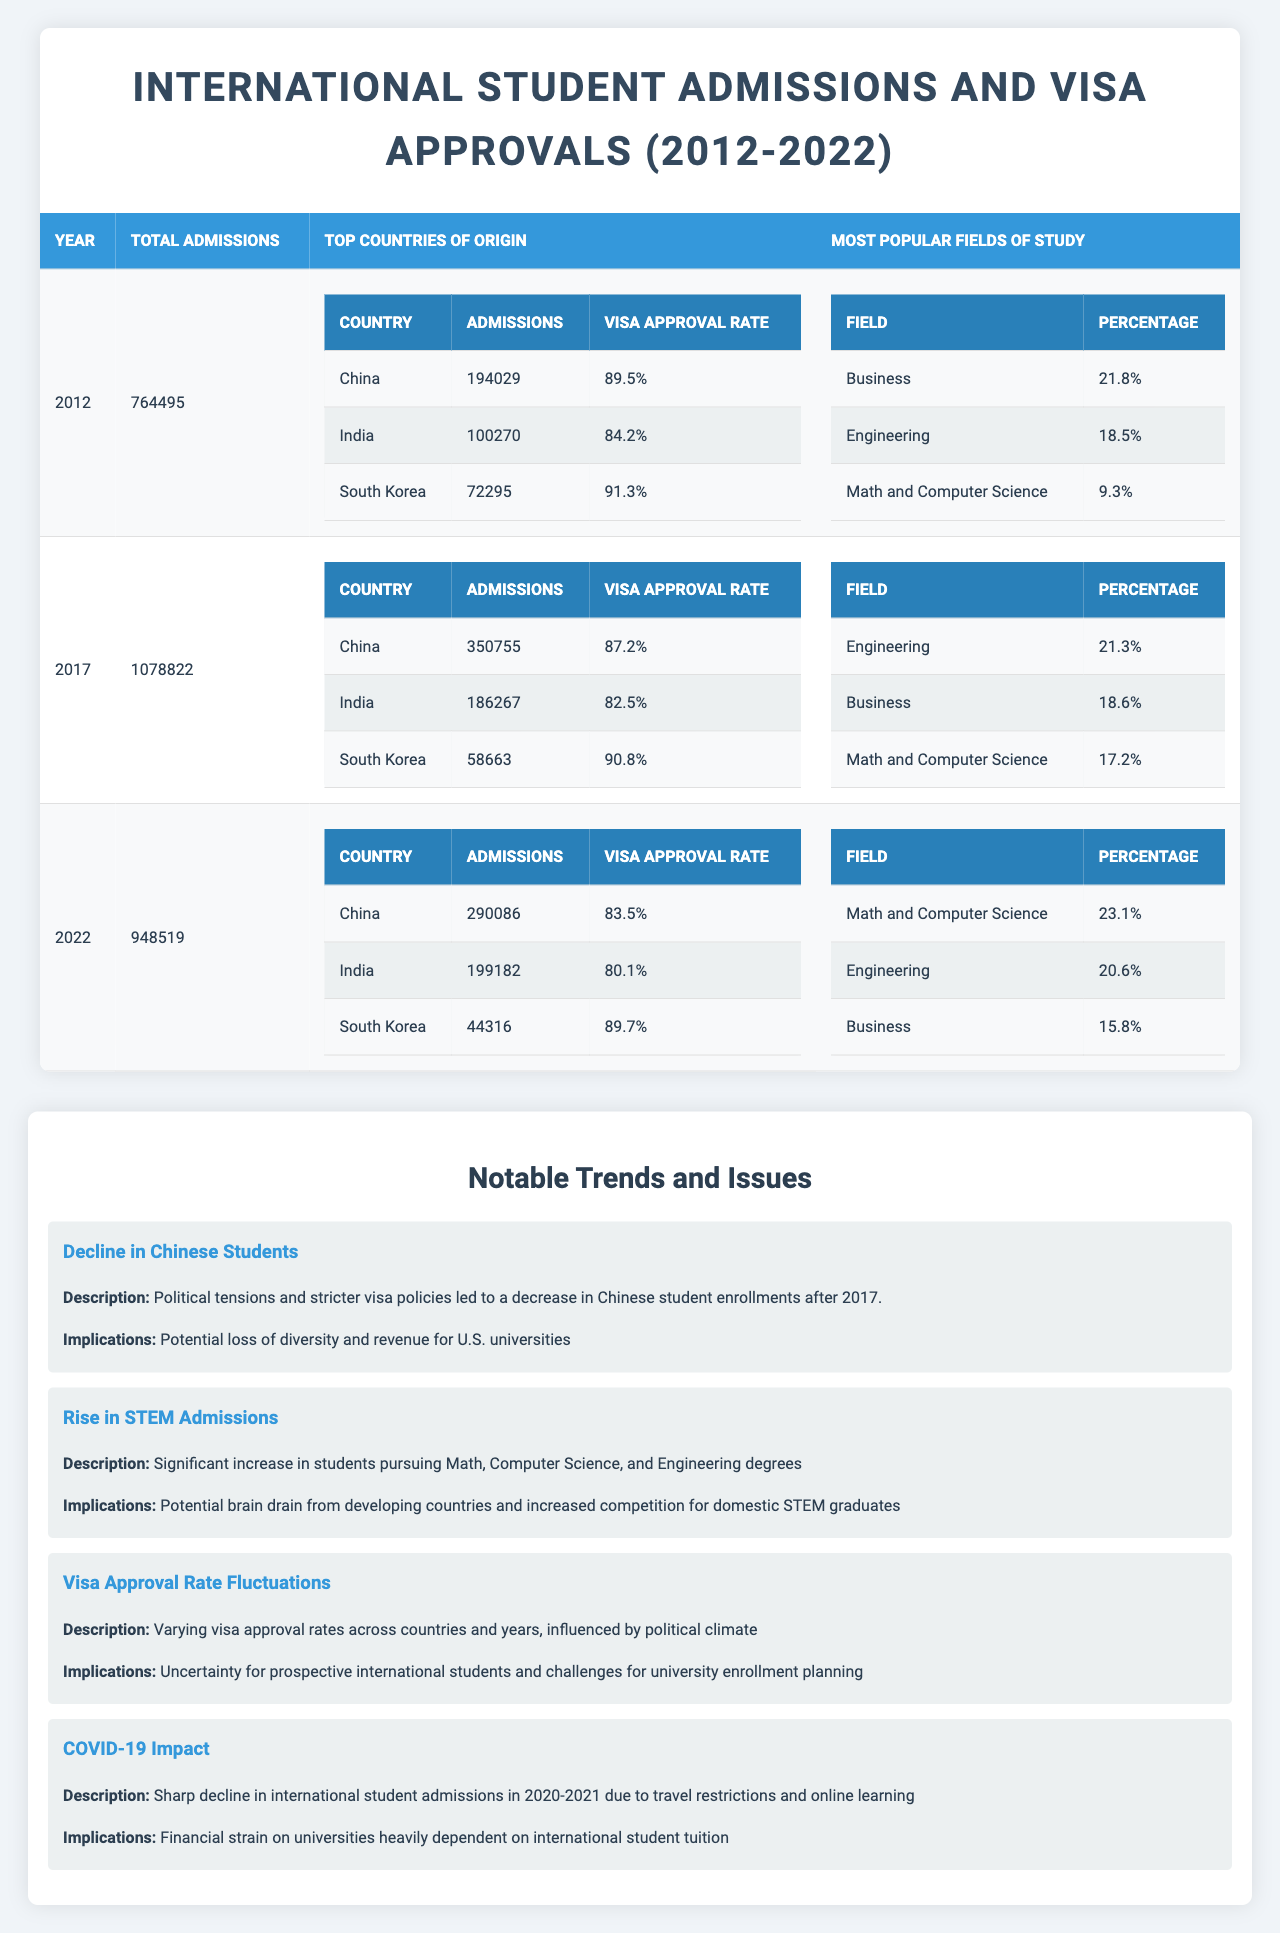What was the total number of international student admissions in 2012? Referring to the table, the total admissions for the year 2012 is listed explicitly. It shows 764,495 admissions for that year.
Answer: 764495 Which country had the highest number of admissions in 2017? The table lists the top countries for 2017, where China had 350,755 admissions, which is the highest compared to India and South Korea.
Answer: China What was the visa approval rate for Indian students in 2022? The data for the year 2022 specifically states that the visa approval rate for Indian students was 80.1%.
Answer: 80.1% How many students from South Korea were admitted in 2012? According to the data presented for 2012, South Korea had 72,295 admissions, specified under the top countries information.
Answer: 72295 In which year did the total admissions peak between 2012 and 2022? By comparing the total admissions across the years, 2017 had the highest total admissions at 1,078,822.
Answer: 2017 What percentage of international students pursued Business in 2022? The table indicates that in 2022, Business accounted for 15.8% of the most popular fields of study.
Answer: 15.8% How many more admissions did China have than India in 2017? In 2017, China had 350,755 admissions while India had 186,267. Subtracting these numbers gives 350,755 - 186,267 = 164,488 more admissions from China.
Answer: 164488 Did the visa approval rate for Chinese students increase or decrease from 2012 to 2022? The approval rate for Chinese students was 89.5% in 2012 and decreased to 83.5% in 2022, indicating a decline.
Answer: Decrease What trend describes the rise in Math and Computer Science degrees since 2012? The "Rise in STEM Admissions" trend notes a significant increase in students pursuing Math and Computer Science, and the data shows this area's percentage grew to 23.1% in 2022.
Answer: Rise in STEM Admissions By how much did the total admissions change from 2017 to 2022? The total admissions went from 1,078,822 in 2017 to 948,519 in 2022. To find the change, subtract the 2022 figure from the 2017 figure: 1,078,822 - 948,519 = 130,303 fewer admissions.
Answer: 130303 